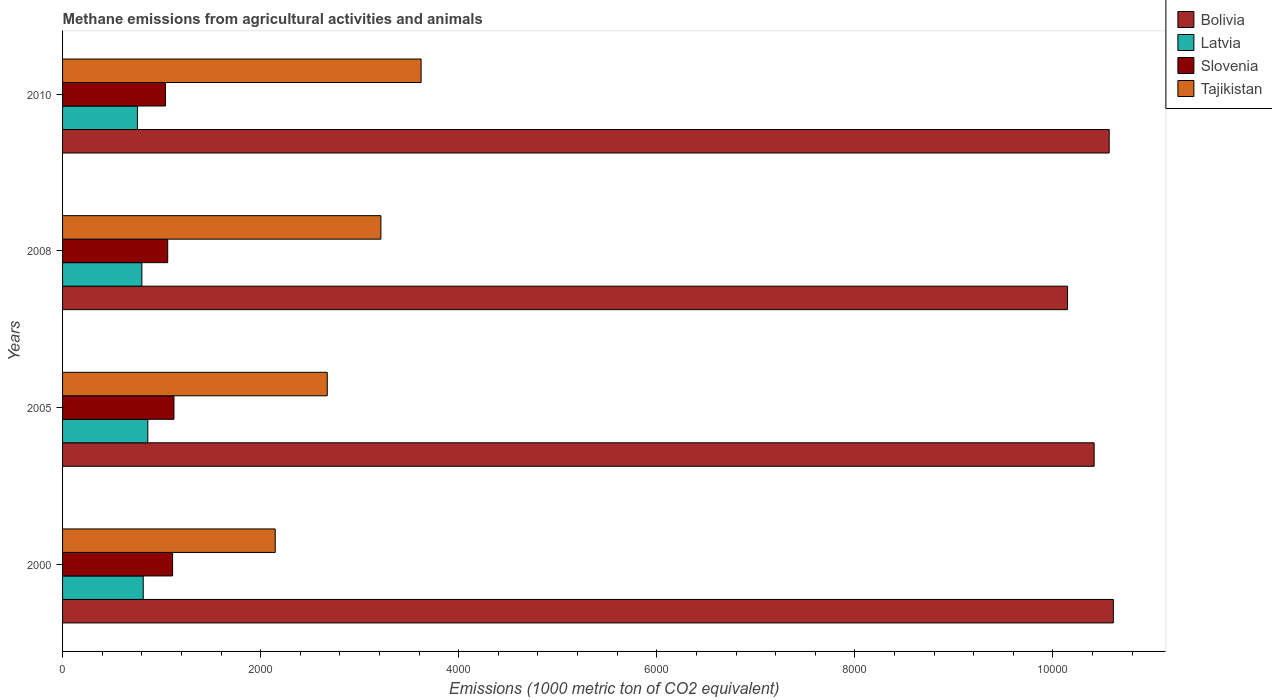How many different coloured bars are there?
Give a very brief answer. 4. How many groups of bars are there?
Give a very brief answer. 4. Are the number of bars per tick equal to the number of legend labels?
Keep it short and to the point. Yes. Are the number of bars on each tick of the Y-axis equal?
Offer a very short reply. Yes. What is the label of the 1st group of bars from the top?
Offer a very short reply. 2010. What is the amount of methane emitted in Latvia in 2000?
Offer a terse response. 814.5. Across all years, what is the maximum amount of methane emitted in Tajikistan?
Offer a terse response. 3620.1. Across all years, what is the minimum amount of methane emitted in Latvia?
Your answer should be compact. 755.9. What is the total amount of methane emitted in Tajikistan in the graph?
Provide a succinct answer. 1.17e+04. What is the difference between the amount of methane emitted in Latvia in 2005 and that in 2008?
Provide a succinct answer. 59.9. What is the difference between the amount of methane emitted in Latvia in 2010 and the amount of methane emitted in Slovenia in 2005?
Ensure brevity in your answer.  -368.7. What is the average amount of methane emitted in Bolivia per year?
Your answer should be compact. 1.04e+04. In the year 2010, what is the difference between the amount of methane emitted in Tajikistan and amount of methane emitted in Slovenia?
Keep it short and to the point. 2580.7. In how many years, is the amount of methane emitted in Latvia greater than 5200 1000 metric ton?
Make the answer very short. 0. What is the ratio of the amount of methane emitted in Slovenia in 2005 to that in 2010?
Your response must be concise. 1.08. Is the amount of methane emitted in Tajikistan in 2000 less than that in 2010?
Make the answer very short. Yes. What is the difference between the highest and the second highest amount of methane emitted in Slovenia?
Make the answer very short. 13.6. What is the difference between the highest and the lowest amount of methane emitted in Slovenia?
Provide a succinct answer. 85.2. In how many years, is the amount of methane emitted in Slovenia greater than the average amount of methane emitted in Slovenia taken over all years?
Provide a succinct answer. 2. Is it the case that in every year, the sum of the amount of methane emitted in Latvia and amount of methane emitted in Tajikistan is greater than the sum of amount of methane emitted in Slovenia and amount of methane emitted in Bolivia?
Make the answer very short. Yes. What does the 1st bar from the top in 2008 represents?
Make the answer very short. Tajikistan. Is it the case that in every year, the sum of the amount of methane emitted in Latvia and amount of methane emitted in Slovenia is greater than the amount of methane emitted in Tajikistan?
Offer a very short reply. No. How many bars are there?
Provide a short and direct response. 16. Are all the bars in the graph horizontal?
Ensure brevity in your answer.  Yes. What is the difference between two consecutive major ticks on the X-axis?
Provide a succinct answer. 2000. Are the values on the major ticks of X-axis written in scientific E-notation?
Offer a very short reply. No. How many legend labels are there?
Your response must be concise. 4. How are the legend labels stacked?
Your response must be concise. Vertical. What is the title of the graph?
Your answer should be compact. Methane emissions from agricultural activities and animals. Does "Pakistan" appear as one of the legend labels in the graph?
Provide a succinct answer. No. What is the label or title of the X-axis?
Keep it short and to the point. Emissions (1000 metric ton of CO2 equivalent). What is the label or title of the Y-axis?
Ensure brevity in your answer.  Years. What is the Emissions (1000 metric ton of CO2 equivalent) in Bolivia in 2000?
Offer a terse response. 1.06e+04. What is the Emissions (1000 metric ton of CO2 equivalent) in Latvia in 2000?
Provide a succinct answer. 814.5. What is the Emissions (1000 metric ton of CO2 equivalent) in Slovenia in 2000?
Provide a short and direct response. 1111. What is the Emissions (1000 metric ton of CO2 equivalent) of Tajikistan in 2000?
Your answer should be compact. 2147.2. What is the Emissions (1000 metric ton of CO2 equivalent) in Bolivia in 2005?
Offer a very short reply. 1.04e+04. What is the Emissions (1000 metric ton of CO2 equivalent) in Latvia in 2005?
Offer a very short reply. 860.7. What is the Emissions (1000 metric ton of CO2 equivalent) of Slovenia in 2005?
Keep it short and to the point. 1124.6. What is the Emissions (1000 metric ton of CO2 equivalent) in Tajikistan in 2005?
Make the answer very short. 2672.7. What is the Emissions (1000 metric ton of CO2 equivalent) in Bolivia in 2008?
Offer a terse response. 1.01e+04. What is the Emissions (1000 metric ton of CO2 equivalent) of Latvia in 2008?
Offer a very short reply. 800.8. What is the Emissions (1000 metric ton of CO2 equivalent) of Slovenia in 2008?
Your answer should be compact. 1061.8. What is the Emissions (1000 metric ton of CO2 equivalent) in Tajikistan in 2008?
Keep it short and to the point. 3214.1. What is the Emissions (1000 metric ton of CO2 equivalent) of Bolivia in 2010?
Give a very brief answer. 1.06e+04. What is the Emissions (1000 metric ton of CO2 equivalent) in Latvia in 2010?
Your answer should be compact. 755.9. What is the Emissions (1000 metric ton of CO2 equivalent) in Slovenia in 2010?
Offer a terse response. 1039.4. What is the Emissions (1000 metric ton of CO2 equivalent) in Tajikistan in 2010?
Keep it short and to the point. 3620.1. Across all years, what is the maximum Emissions (1000 metric ton of CO2 equivalent) of Bolivia?
Your answer should be very brief. 1.06e+04. Across all years, what is the maximum Emissions (1000 metric ton of CO2 equivalent) in Latvia?
Provide a short and direct response. 860.7. Across all years, what is the maximum Emissions (1000 metric ton of CO2 equivalent) of Slovenia?
Ensure brevity in your answer.  1124.6. Across all years, what is the maximum Emissions (1000 metric ton of CO2 equivalent) of Tajikistan?
Offer a very short reply. 3620.1. Across all years, what is the minimum Emissions (1000 metric ton of CO2 equivalent) in Bolivia?
Make the answer very short. 1.01e+04. Across all years, what is the minimum Emissions (1000 metric ton of CO2 equivalent) in Latvia?
Make the answer very short. 755.9. Across all years, what is the minimum Emissions (1000 metric ton of CO2 equivalent) in Slovenia?
Your answer should be very brief. 1039.4. Across all years, what is the minimum Emissions (1000 metric ton of CO2 equivalent) of Tajikistan?
Keep it short and to the point. 2147.2. What is the total Emissions (1000 metric ton of CO2 equivalent) of Bolivia in the graph?
Your response must be concise. 4.17e+04. What is the total Emissions (1000 metric ton of CO2 equivalent) in Latvia in the graph?
Provide a short and direct response. 3231.9. What is the total Emissions (1000 metric ton of CO2 equivalent) of Slovenia in the graph?
Make the answer very short. 4336.8. What is the total Emissions (1000 metric ton of CO2 equivalent) of Tajikistan in the graph?
Offer a terse response. 1.17e+04. What is the difference between the Emissions (1000 metric ton of CO2 equivalent) of Bolivia in 2000 and that in 2005?
Give a very brief answer. 193.9. What is the difference between the Emissions (1000 metric ton of CO2 equivalent) in Latvia in 2000 and that in 2005?
Your answer should be compact. -46.2. What is the difference between the Emissions (1000 metric ton of CO2 equivalent) of Tajikistan in 2000 and that in 2005?
Give a very brief answer. -525.5. What is the difference between the Emissions (1000 metric ton of CO2 equivalent) of Bolivia in 2000 and that in 2008?
Ensure brevity in your answer.  462.2. What is the difference between the Emissions (1000 metric ton of CO2 equivalent) of Slovenia in 2000 and that in 2008?
Provide a succinct answer. 49.2. What is the difference between the Emissions (1000 metric ton of CO2 equivalent) of Tajikistan in 2000 and that in 2008?
Offer a very short reply. -1066.9. What is the difference between the Emissions (1000 metric ton of CO2 equivalent) in Bolivia in 2000 and that in 2010?
Your answer should be very brief. 42. What is the difference between the Emissions (1000 metric ton of CO2 equivalent) in Latvia in 2000 and that in 2010?
Ensure brevity in your answer.  58.6. What is the difference between the Emissions (1000 metric ton of CO2 equivalent) in Slovenia in 2000 and that in 2010?
Your answer should be very brief. 71.6. What is the difference between the Emissions (1000 metric ton of CO2 equivalent) in Tajikistan in 2000 and that in 2010?
Give a very brief answer. -1472.9. What is the difference between the Emissions (1000 metric ton of CO2 equivalent) in Bolivia in 2005 and that in 2008?
Keep it short and to the point. 268.3. What is the difference between the Emissions (1000 metric ton of CO2 equivalent) in Latvia in 2005 and that in 2008?
Your response must be concise. 59.9. What is the difference between the Emissions (1000 metric ton of CO2 equivalent) in Slovenia in 2005 and that in 2008?
Provide a succinct answer. 62.8. What is the difference between the Emissions (1000 metric ton of CO2 equivalent) of Tajikistan in 2005 and that in 2008?
Offer a very short reply. -541.4. What is the difference between the Emissions (1000 metric ton of CO2 equivalent) of Bolivia in 2005 and that in 2010?
Your answer should be compact. -151.9. What is the difference between the Emissions (1000 metric ton of CO2 equivalent) in Latvia in 2005 and that in 2010?
Provide a short and direct response. 104.8. What is the difference between the Emissions (1000 metric ton of CO2 equivalent) of Slovenia in 2005 and that in 2010?
Offer a very short reply. 85.2. What is the difference between the Emissions (1000 metric ton of CO2 equivalent) in Tajikistan in 2005 and that in 2010?
Your response must be concise. -947.4. What is the difference between the Emissions (1000 metric ton of CO2 equivalent) of Bolivia in 2008 and that in 2010?
Provide a short and direct response. -420.2. What is the difference between the Emissions (1000 metric ton of CO2 equivalent) of Latvia in 2008 and that in 2010?
Offer a very short reply. 44.9. What is the difference between the Emissions (1000 metric ton of CO2 equivalent) of Slovenia in 2008 and that in 2010?
Offer a terse response. 22.4. What is the difference between the Emissions (1000 metric ton of CO2 equivalent) of Tajikistan in 2008 and that in 2010?
Provide a succinct answer. -406. What is the difference between the Emissions (1000 metric ton of CO2 equivalent) in Bolivia in 2000 and the Emissions (1000 metric ton of CO2 equivalent) in Latvia in 2005?
Provide a succinct answer. 9749. What is the difference between the Emissions (1000 metric ton of CO2 equivalent) in Bolivia in 2000 and the Emissions (1000 metric ton of CO2 equivalent) in Slovenia in 2005?
Give a very brief answer. 9485.1. What is the difference between the Emissions (1000 metric ton of CO2 equivalent) of Bolivia in 2000 and the Emissions (1000 metric ton of CO2 equivalent) of Tajikistan in 2005?
Your answer should be very brief. 7937. What is the difference between the Emissions (1000 metric ton of CO2 equivalent) of Latvia in 2000 and the Emissions (1000 metric ton of CO2 equivalent) of Slovenia in 2005?
Make the answer very short. -310.1. What is the difference between the Emissions (1000 metric ton of CO2 equivalent) of Latvia in 2000 and the Emissions (1000 metric ton of CO2 equivalent) of Tajikistan in 2005?
Keep it short and to the point. -1858.2. What is the difference between the Emissions (1000 metric ton of CO2 equivalent) of Slovenia in 2000 and the Emissions (1000 metric ton of CO2 equivalent) of Tajikistan in 2005?
Make the answer very short. -1561.7. What is the difference between the Emissions (1000 metric ton of CO2 equivalent) in Bolivia in 2000 and the Emissions (1000 metric ton of CO2 equivalent) in Latvia in 2008?
Keep it short and to the point. 9808.9. What is the difference between the Emissions (1000 metric ton of CO2 equivalent) in Bolivia in 2000 and the Emissions (1000 metric ton of CO2 equivalent) in Slovenia in 2008?
Your answer should be very brief. 9547.9. What is the difference between the Emissions (1000 metric ton of CO2 equivalent) in Bolivia in 2000 and the Emissions (1000 metric ton of CO2 equivalent) in Tajikistan in 2008?
Provide a short and direct response. 7395.6. What is the difference between the Emissions (1000 metric ton of CO2 equivalent) of Latvia in 2000 and the Emissions (1000 metric ton of CO2 equivalent) of Slovenia in 2008?
Offer a very short reply. -247.3. What is the difference between the Emissions (1000 metric ton of CO2 equivalent) in Latvia in 2000 and the Emissions (1000 metric ton of CO2 equivalent) in Tajikistan in 2008?
Give a very brief answer. -2399.6. What is the difference between the Emissions (1000 metric ton of CO2 equivalent) in Slovenia in 2000 and the Emissions (1000 metric ton of CO2 equivalent) in Tajikistan in 2008?
Offer a terse response. -2103.1. What is the difference between the Emissions (1000 metric ton of CO2 equivalent) in Bolivia in 2000 and the Emissions (1000 metric ton of CO2 equivalent) in Latvia in 2010?
Give a very brief answer. 9853.8. What is the difference between the Emissions (1000 metric ton of CO2 equivalent) in Bolivia in 2000 and the Emissions (1000 metric ton of CO2 equivalent) in Slovenia in 2010?
Your response must be concise. 9570.3. What is the difference between the Emissions (1000 metric ton of CO2 equivalent) in Bolivia in 2000 and the Emissions (1000 metric ton of CO2 equivalent) in Tajikistan in 2010?
Keep it short and to the point. 6989.6. What is the difference between the Emissions (1000 metric ton of CO2 equivalent) in Latvia in 2000 and the Emissions (1000 metric ton of CO2 equivalent) in Slovenia in 2010?
Provide a succinct answer. -224.9. What is the difference between the Emissions (1000 metric ton of CO2 equivalent) of Latvia in 2000 and the Emissions (1000 metric ton of CO2 equivalent) of Tajikistan in 2010?
Give a very brief answer. -2805.6. What is the difference between the Emissions (1000 metric ton of CO2 equivalent) of Slovenia in 2000 and the Emissions (1000 metric ton of CO2 equivalent) of Tajikistan in 2010?
Offer a terse response. -2509.1. What is the difference between the Emissions (1000 metric ton of CO2 equivalent) in Bolivia in 2005 and the Emissions (1000 metric ton of CO2 equivalent) in Latvia in 2008?
Your answer should be very brief. 9615. What is the difference between the Emissions (1000 metric ton of CO2 equivalent) in Bolivia in 2005 and the Emissions (1000 metric ton of CO2 equivalent) in Slovenia in 2008?
Make the answer very short. 9354. What is the difference between the Emissions (1000 metric ton of CO2 equivalent) in Bolivia in 2005 and the Emissions (1000 metric ton of CO2 equivalent) in Tajikistan in 2008?
Your answer should be very brief. 7201.7. What is the difference between the Emissions (1000 metric ton of CO2 equivalent) of Latvia in 2005 and the Emissions (1000 metric ton of CO2 equivalent) of Slovenia in 2008?
Offer a terse response. -201.1. What is the difference between the Emissions (1000 metric ton of CO2 equivalent) of Latvia in 2005 and the Emissions (1000 metric ton of CO2 equivalent) of Tajikistan in 2008?
Ensure brevity in your answer.  -2353.4. What is the difference between the Emissions (1000 metric ton of CO2 equivalent) of Slovenia in 2005 and the Emissions (1000 metric ton of CO2 equivalent) of Tajikistan in 2008?
Give a very brief answer. -2089.5. What is the difference between the Emissions (1000 metric ton of CO2 equivalent) of Bolivia in 2005 and the Emissions (1000 metric ton of CO2 equivalent) of Latvia in 2010?
Give a very brief answer. 9659.9. What is the difference between the Emissions (1000 metric ton of CO2 equivalent) in Bolivia in 2005 and the Emissions (1000 metric ton of CO2 equivalent) in Slovenia in 2010?
Provide a short and direct response. 9376.4. What is the difference between the Emissions (1000 metric ton of CO2 equivalent) in Bolivia in 2005 and the Emissions (1000 metric ton of CO2 equivalent) in Tajikistan in 2010?
Provide a succinct answer. 6795.7. What is the difference between the Emissions (1000 metric ton of CO2 equivalent) of Latvia in 2005 and the Emissions (1000 metric ton of CO2 equivalent) of Slovenia in 2010?
Make the answer very short. -178.7. What is the difference between the Emissions (1000 metric ton of CO2 equivalent) of Latvia in 2005 and the Emissions (1000 metric ton of CO2 equivalent) of Tajikistan in 2010?
Ensure brevity in your answer.  -2759.4. What is the difference between the Emissions (1000 metric ton of CO2 equivalent) in Slovenia in 2005 and the Emissions (1000 metric ton of CO2 equivalent) in Tajikistan in 2010?
Provide a succinct answer. -2495.5. What is the difference between the Emissions (1000 metric ton of CO2 equivalent) in Bolivia in 2008 and the Emissions (1000 metric ton of CO2 equivalent) in Latvia in 2010?
Your answer should be very brief. 9391.6. What is the difference between the Emissions (1000 metric ton of CO2 equivalent) in Bolivia in 2008 and the Emissions (1000 metric ton of CO2 equivalent) in Slovenia in 2010?
Provide a succinct answer. 9108.1. What is the difference between the Emissions (1000 metric ton of CO2 equivalent) in Bolivia in 2008 and the Emissions (1000 metric ton of CO2 equivalent) in Tajikistan in 2010?
Your answer should be very brief. 6527.4. What is the difference between the Emissions (1000 metric ton of CO2 equivalent) of Latvia in 2008 and the Emissions (1000 metric ton of CO2 equivalent) of Slovenia in 2010?
Provide a succinct answer. -238.6. What is the difference between the Emissions (1000 metric ton of CO2 equivalent) of Latvia in 2008 and the Emissions (1000 metric ton of CO2 equivalent) of Tajikistan in 2010?
Your answer should be compact. -2819.3. What is the difference between the Emissions (1000 metric ton of CO2 equivalent) in Slovenia in 2008 and the Emissions (1000 metric ton of CO2 equivalent) in Tajikistan in 2010?
Ensure brevity in your answer.  -2558.3. What is the average Emissions (1000 metric ton of CO2 equivalent) in Bolivia per year?
Keep it short and to the point. 1.04e+04. What is the average Emissions (1000 metric ton of CO2 equivalent) of Latvia per year?
Offer a terse response. 807.98. What is the average Emissions (1000 metric ton of CO2 equivalent) in Slovenia per year?
Make the answer very short. 1084.2. What is the average Emissions (1000 metric ton of CO2 equivalent) of Tajikistan per year?
Keep it short and to the point. 2913.53. In the year 2000, what is the difference between the Emissions (1000 metric ton of CO2 equivalent) in Bolivia and Emissions (1000 metric ton of CO2 equivalent) in Latvia?
Provide a succinct answer. 9795.2. In the year 2000, what is the difference between the Emissions (1000 metric ton of CO2 equivalent) of Bolivia and Emissions (1000 metric ton of CO2 equivalent) of Slovenia?
Offer a very short reply. 9498.7. In the year 2000, what is the difference between the Emissions (1000 metric ton of CO2 equivalent) in Bolivia and Emissions (1000 metric ton of CO2 equivalent) in Tajikistan?
Ensure brevity in your answer.  8462.5. In the year 2000, what is the difference between the Emissions (1000 metric ton of CO2 equivalent) of Latvia and Emissions (1000 metric ton of CO2 equivalent) of Slovenia?
Make the answer very short. -296.5. In the year 2000, what is the difference between the Emissions (1000 metric ton of CO2 equivalent) of Latvia and Emissions (1000 metric ton of CO2 equivalent) of Tajikistan?
Give a very brief answer. -1332.7. In the year 2000, what is the difference between the Emissions (1000 metric ton of CO2 equivalent) in Slovenia and Emissions (1000 metric ton of CO2 equivalent) in Tajikistan?
Keep it short and to the point. -1036.2. In the year 2005, what is the difference between the Emissions (1000 metric ton of CO2 equivalent) of Bolivia and Emissions (1000 metric ton of CO2 equivalent) of Latvia?
Make the answer very short. 9555.1. In the year 2005, what is the difference between the Emissions (1000 metric ton of CO2 equivalent) of Bolivia and Emissions (1000 metric ton of CO2 equivalent) of Slovenia?
Keep it short and to the point. 9291.2. In the year 2005, what is the difference between the Emissions (1000 metric ton of CO2 equivalent) of Bolivia and Emissions (1000 metric ton of CO2 equivalent) of Tajikistan?
Provide a succinct answer. 7743.1. In the year 2005, what is the difference between the Emissions (1000 metric ton of CO2 equivalent) of Latvia and Emissions (1000 metric ton of CO2 equivalent) of Slovenia?
Offer a very short reply. -263.9. In the year 2005, what is the difference between the Emissions (1000 metric ton of CO2 equivalent) of Latvia and Emissions (1000 metric ton of CO2 equivalent) of Tajikistan?
Provide a short and direct response. -1812. In the year 2005, what is the difference between the Emissions (1000 metric ton of CO2 equivalent) of Slovenia and Emissions (1000 metric ton of CO2 equivalent) of Tajikistan?
Make the answer very short. -1548.1. In the year 2008, what is the difference between the Emissions (1000 metric ton of CO2 equivalent) in Bolivia and Emissions (1000 metric ton of CO2 equivalent) in Latvia?
Provide a short and direct response. 9346.7. In the year 2008, what is the difference between the Emissions (1000 metric ton of CO2 equivalent) of Bolivia and Emissions (1000 metric ton of CO2 equivalent) of Slovenia?
Ensure brevity in your answer.  9085.7. In the year 2008, what is the difference between the Emissions (1000 metric ton of CO2 equivalent) of Bolivia and Emissions (1000 metric ton of CO2 equivalent) of Tajikistan?
Provide a short and direct response. 6933.4. In the year 2008, what is the difference between the Emissions (1000 metric ton of CO2 equivalent) of Latvia and Emissions (1000 metric ton of CO2 equivalent) of Slovenia?
Offer a very short reply. -261. In the year 2008, what is the difference between the Emissions (1000 metric ton of CO2 equivalent) of Latvia and Emissions (1000 metric ton of CO2 equivalent) of Tajikistan?
Your answer should be very brief. -2413.3. In the year 2008, what is the difference between the Emissions (1000 metric ton of CO2 equivalent) of Slovenia and Emissions (1000 metric ton of CO2 equivalent) of Tajikistan?
Offer a very short reply. -2152.3. In the year 2010, what is the difference between the Emissions (1000 metric ton of CO2 equivalent) in Bolivia and Emissions (1000 metric ton of CO2 equivalent) in Latvia?
Offer a very short reply. 9811.8. In the year 2010, what is the difference between the Emissions (1000 metric ton of CO2 equivalent) of Bolivia and Emissions (1000 metric ton of CO2 equivalent) of Slovenia?
Offer a very short reply. 9528.3. In the year 2010, what is the difference between the Emissions (1000 metric ton of CO2 equivalent) of Bolivia and Emissions (1000 metric ton of CO2 equivalent) of Tajikistan?
Your response must be concise. 6947.6. In the year 2010, what is the difference between the Emissions (1000 metric ton of CO2 equivalent) of Latvia and Emissions (1000 metric ton of CO2 equivalent) of Slovenia?
Provide a short and direct response. -283.5. In the year 2010, what is the difference between the Emissions (1000 metric ton of CO2 equivalent) in Latvia and Emissions (1000 metric ton of CO2 equivalent) in Tajikistan?
Ensure brevity in your answer.  -2864.2. In the year 2010, what is the difference between the Emissions (1000 metric ton of CO2 equivalent) in Slovenia and Emissions (1000 metric ton of CO2 equivalent) in Tajikistan?
Provide a succinct answer. -2580.7. What is the ratio of the Emissions (1000 metric ton of CO2 equivalent) of Bolivia in 2000 to that in 2005?
Provide a short and direct response. 1.02. What is the ratio of the Emissions (1000 metric ton of CO2 equivalent) in Latvia in 2000 to that in 2005?
Your answer should be compact. 0.95. What is the ratio of the Emissions (1000 metric ton of CO2 equivalent) of Slovenia in 2000 to that in 2005?
Provide a short and direct response. 0.99. What is the ratio of the Emissions (1000 metric ton of CO2 equivalent) of Tajikistan in 2000 to that in 2005?
Keep it short and to the point. 0.8. What is the ratio of the Emissions (1000 metric ton of CO2 equivalent) of Bolivia in 2000 to that in 2008?
Offer a terse response. 1.05. What is the ratio of the Emissions (1000 metric ton of CO2 equivalent) in Latvia in 2000 to that in 2008?
Your answer should be compact. 1.02. What is the ratio of the Emissions (1000 metric ton of CO2 equivalent) in Slovenia in 2000 to that in 2008?
Offer a very short reply. 1.05. What is the ratio of the Emissions (1000 metric ton of CO2 equivalent) in Tajikistan in 2000 to that in 2008?
Your answer should be compact. 0.67. What is the ratio of the Emissions (1000 metric ton of CO2 equivalent) of Bolivia in 2000 to that in 2010?
Give a very brief answer. 1. What is the ratio of the Emissions (1000 metric ton of CO2 equivalent) of Latvia in 2000 to that in 2010?
Offer a very short reply. 1.08. What is the ratio of the Emissions (1000 metric ton of CO2 equivalent) in Slovenia in 2000 to that in 2010?
Your answer should be compact. 1.07. What is the ratio of the Emissions (1000 metric ton of CO2 equivalent) in Tajikistan in 2000 to that in 2010?
Provide a succinct answer. 0.59. What is the ratio of the Emissions (1000 metric ton of CO2 equivalent) in Bolivia in 2005 to that in 2008?
Make the answer very short. 1.03. What is the ratio of the Emissions (1000 metric ton of CO2 equivalent) of Latvia in 2005 to that in 2008?
Keep it short and to the point. 1.07. What is the ratio of the Emissions (1000 metric ton of CO2 equivalent) in Slovenia in 2005 to that in 2008?
Your response must be concise. 1.06. What is the ratio of the Emissions (1000 metric ton of CO2 equivalent) in Tajikistan in 2005 to that in 2008?
Provide a short and direct response. 0.83. What is the ratio of the Emissions (1000 metric ton of CO2 equivalent) of Bolivia in 2005 to that in 2010?
Offer a terse response. 0.99. What is the ratio of the Emissions (1000 metric ton of CO2 equivalent) of Latvia in 2005 to that in 2010?
Provide a succinct answer. 1.14. What is the ratio of the Emissions (1000 metric ton of CO2 equivalent) of Slovenia in 2005 to that in 2010?
Provide a short and direct response. 1.08. What is the ratio of the Emissions (1000 metric ton of CO2 equivalent) of Tajikistan in 2005 to that in 2010?
Make the answer very short. 0.74. What is the ratio of the Emissions (1000 metric ton of CO2 equivalent) of Bolivia in 2008 to that in 2010?
Keep it short and to the point. 0.96. What is the ratio of the Emissions (1000 metric ton of CO2 equivalent) of Latvia in 2008 to that in 2010?
Provide a succinct answer. 1.06. What is the ratio of the Emissions (1000 metric ton of CO2 equivalent) in Slovenia in 2008 to that in 2010?
Make the answer very short. 1.02. What is the ratio of the Emissions (1000 metric ton of CO2 equivalent) of Tajikistan in 2008 to that in 2010?
Ensure brevity in your answer.  0.89. What is the difference between the highest and the second highest Emissions (1000 metric ton of CO2 equivalent) in Bolivia?
Ensure brevity in your answer.  42. What is the difference between the highest and the second highest Emissions (1000 metric ton of CO2 equivalent) of Latvia?
Your answer should be compact. 46.2. What is the difference between the highest and the second highest Emissions (1000 metric ton of CO2 equivalent) in Slovenia?
Provide a short and direct response. 13.6. What is the difference between the highest and the second highest Emissions (1000 metric ton of CO2 equivalent) of Tajikistan?
Give a very brief answer. 406. What is the difference between the highest and the lowest Emissions (1000 metric ton of CO2 equivalent) in Bolivia?
Provide a short and direct response. 462.2. What is the difference between the highest and the lowest Emissions (1000 metric ton of CO2 equivalent) of Latvia?
Provide a short and direct response. 104.8. What is the difference between the highest and the lowest Emissions (1000 metric ton of CO2 equivalent) in Slovenia?
Keep it short and to the point. 85.2. What is the difference between the highest and the lowest Emissions (1000 metric ton of CO2 equivalent) of Tajikistan?
Keep it short and to the point. 1472.9. 